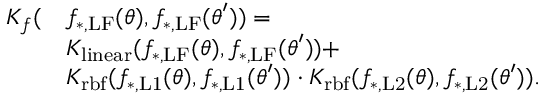<formula> <loc_0><loc_0><loc_500><loc_500>\begin{array} { r l } { K _ { f } ( } & { f _ { * , L F } ( \theta ) , f _ { * , L F } ( \theta ^ { \prime } ) ) = } \\ & { K _ { l i n e a r } ( f _ { * , L F } ( \theta ) , f _ { * , L F } ( \theta ^ { \prime } ) ) + } \\ & { K _ { r b f } ( f _ { * , L 1 } ( \theta ) , f _ { * , L 1 } ( \theta ^ { \prime } ) ) \cdot K _ { r b f } ( f _ { * , L 2 } ( \theta ) , f _ { * , L 2 } ( \theta ^ { \prime } ) ) . } \end{array}</formula> 